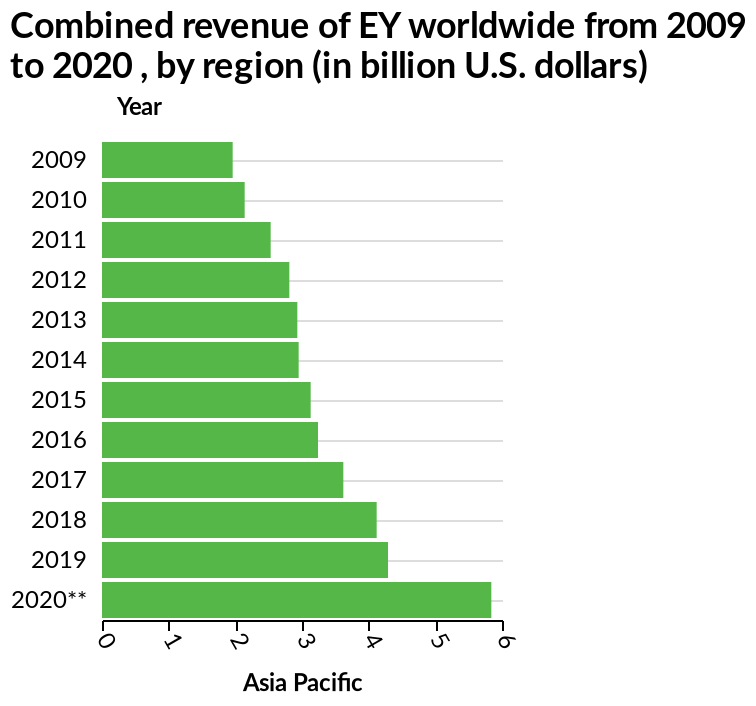<image>
How long has the combined revenue of EY Worldwide been consistently increasing? The combined revenue of EY Worldwide has been consistently increasing for over 10 years since 2009. What is the range of values on the x-axis?  The range of values on the x-axis is from 0 to 6. What is the earliest and latest year represented on the y-axis? The earliest year represented on the y-axis is 2009, while the latest year is 2020. 